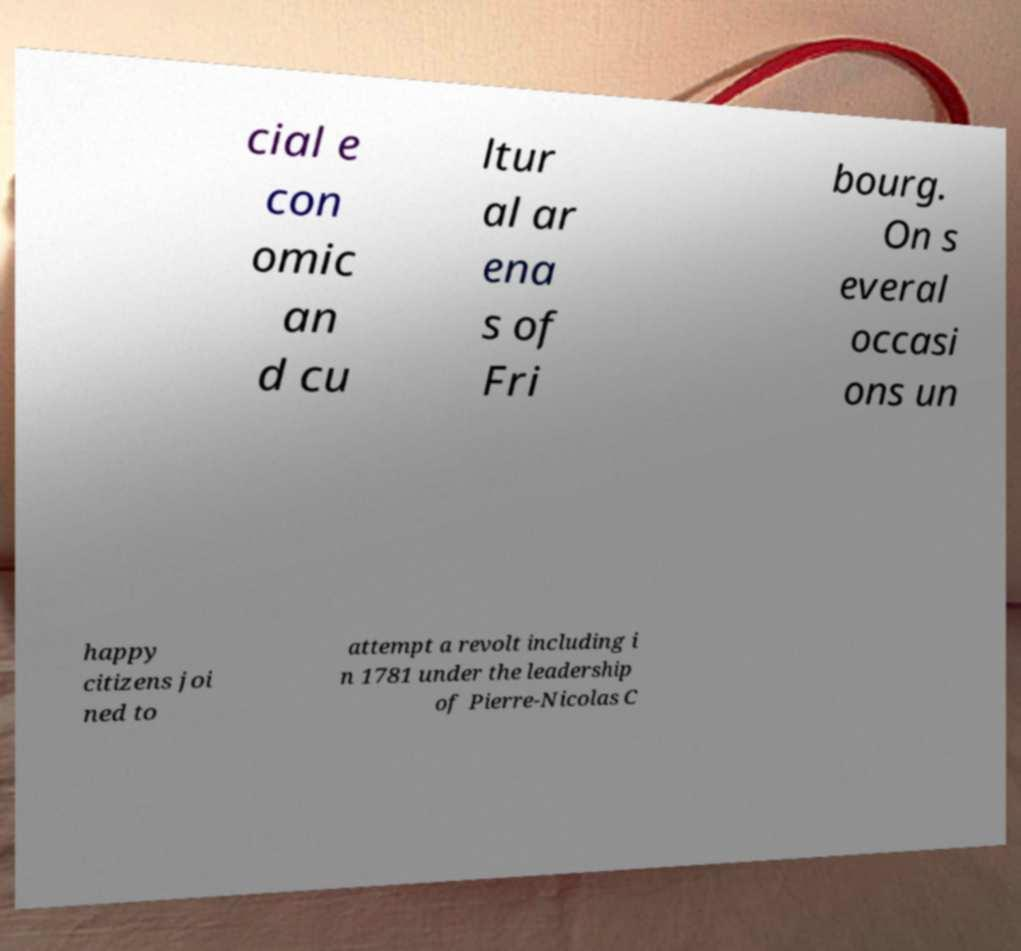I need the written content from this picture converted into text. Can you do that? cial e con omic an d cu ltur al ar ena s of Fri bourg. On s everal occasi ons un happy citizens joi ned to attempt a revolt including i n 1781 under the leadership of Pierre-Nicolas C 